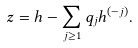<formula> <loc_0><loc_0><loc_500><loc_500>z = h - \sum _ { j \geq 1 } q _ { j } h ^ { ( - j ) } .</formula> 